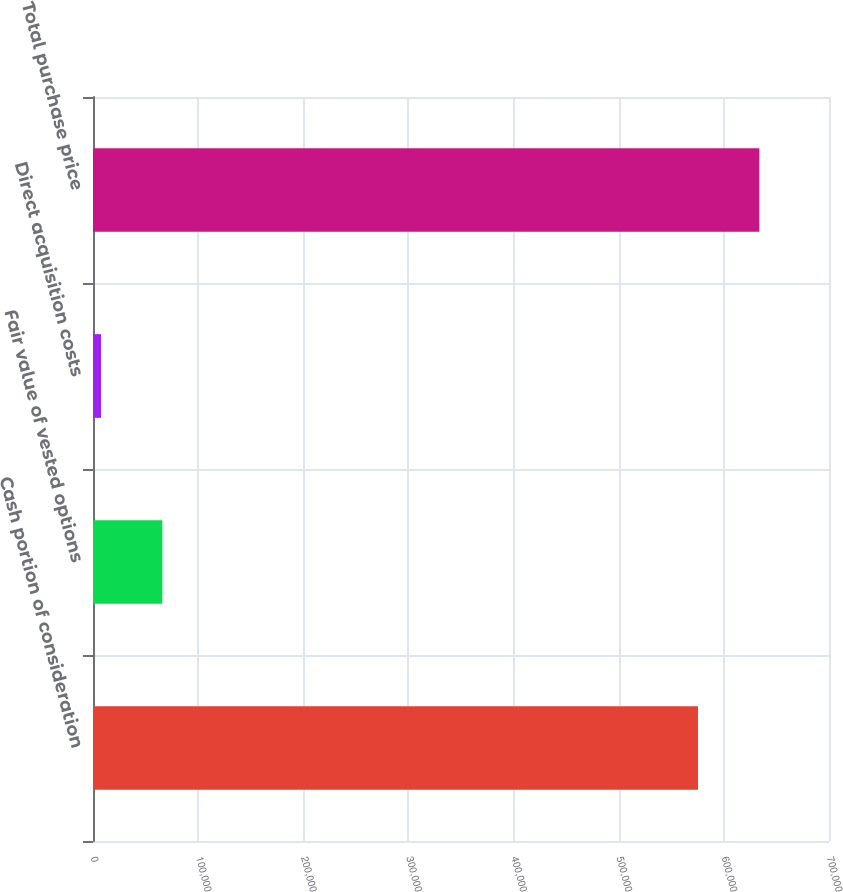Convert chart. <chart><loc_0><loc_0><loc_500><loc_500><bar_chart><fcel>Cash portion of consideration<fcel>Fair value of vested options<fcel>Direct acquisition costs<fcel>Total purchase price<nl><fcel>575400<fcel>65950<fcel>7600<fcel>633750<nl></chart> 